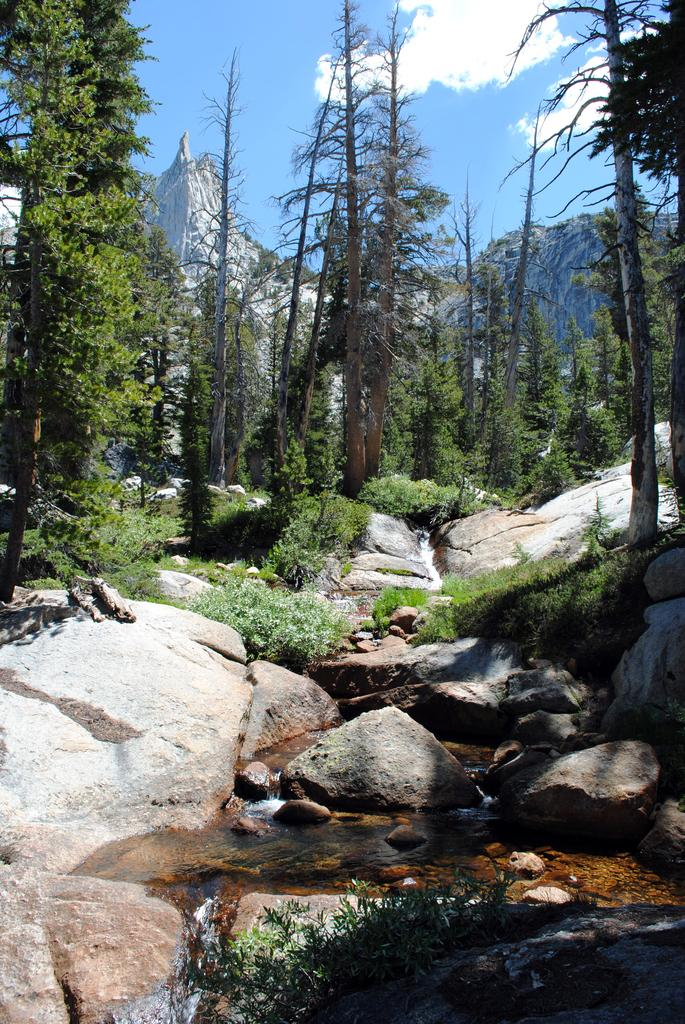What type of natural elements can be seen in the image? There are rocks, trees, hills, and plants visible in the image. What part of the natural environment is visible in the image? The sky is visible in the image. Can you describe the terrain in the image? The terrain in the image includes hills and rocks. What is the argument about between the rocks and the trees in the image? There is no argument present in the image, as it features natural elements such as rocks and trees. 